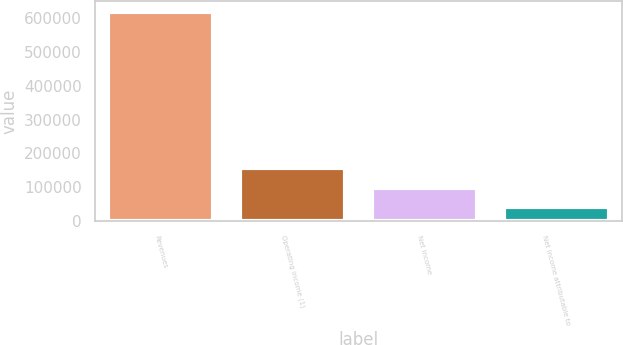<chart> <loc_0><loc_0><loc_500><loc_500><bar_chart><fcel>Revenues<fcel>Operating income (1)<fcel>Net income<fcel>Net income attributable to<nl><fcel>618352<fcel>156314<fcel>98559.7<fcel>40805<nl></chart> 